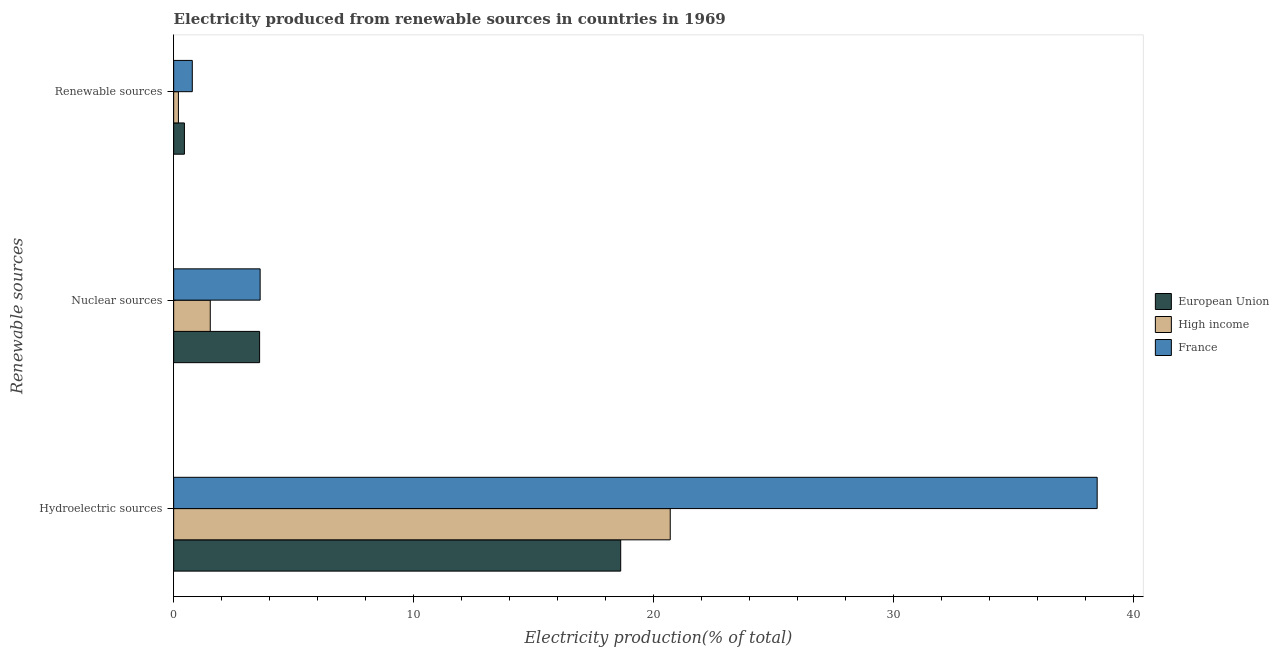How many different coloured bars are there?
Provide a short and direct response. 3. How many groups of bars are there?
Ensure brevity in your answer.  3. Are the number of bars per tick equal to the number of legend labels?
Offer a very short reply. Yes. How many bars are there on the 1st tick from the top?
Offer a very short reply. 3. How many bars are there on the 2nd tick from the bottom?
Offer a very short reply. 3. What is the label of the 1st group of bars from the top?
Provide a short and direct response. Renewable sources. What is the percentage of electricity produced by nuclear sources in France?
Ensure brevity in your answer.  3.6. Across all countries, what is the maximum percentage of electricity produced by nuclear sources?
Ensure brevity in your answer.  3.6. Across all countries, what is the minimum percentage of electricity produced by renewable sources?
Give a very brief answer. 0.2. What is the total percentage of electricity produced by nuclear sources in the graph?
Your answer should be compact. 8.71. What is the difference between the percentage of electricity produced by renewable sources in France and that in High income?
Provide a short and direct response. 0.58. What is the difference between the percentage of electricity produced by renewable sources in High income and the percentage of electricity produced by nuclear sources in European Union?
Your response must be concise. -3.38. What is the average percentage of electricity produced by hydroelectric sources per country?
Make the answer very short. 25.95. What is the difference between the percentage of electricity produced by renewable sources and percentage of electricity produced by hydroelectric sources in European Union?
Provide a short and direct response. -18.19. In how many countries, is the percentage of electricity produced by renewable sources greater than 32 %?
Give a very brief answer. 0. What is the ratio of the percentage of electricity produced by renewable sources in High income to that in European Union?
Your answer should be very brief. 0.44. Is the difference between the percentage of electricity produced by hydroelectric sources in France and High income greater than the difference between the percentage of electricity produced by nuclear sources in France and High income?
Your answer should be very brief. Yes. What is the difference between the highest and the second highest percentage of electricity produced by renewable sources?
Give a very brief answer. 0.33. What is the difference between the highest and the lowest percentage of electricity produced by hydroelectric sources?
Your answer should be compact. 19.87. What does the 2nd bar from the top in Hydroelectric sources represents?
Provide a succinct answer. High income. Is it the case that in every country, the sum of the percentage of electricity produced by hydroelectric sources and percentage of electricity produced by nuclear sources is greater than the percentage of electricity produced by renewable sources?
Make the answer very short. Yes. How many bars are there?
Ensure brevity in your answer.  9. Are all the bars in the graph horizontal?
Keep it short and to the point. Yes. What is the difference between two consecutive major ticks on the X-axis?
Provide a succinct answer. 10. Where does the legend appear in the graph?
Ensure brevity in your answer.  Center right. How many legend labels are there?
Your answer should be compact. 3. How are the legend labels stacked?
Offer a very short reply. Vertical. What is the title of the graph?
Make the answer very short. Electricity produced from renewable sources in countries in 1969. Does "Albania" appear as one of the legend labels in the graph?
Offer a very short reply. No. What is the label or title of the X-axis?
Your response must be concise. Electricity production(% of total). What is the label or title of the Y-axis?
Your response must be concise. Renewable sources. What is the Electricity production(% of total) in European Union in Hydroelectric sources?
Ensure brevity in your answer.  18.64. What is the Electricity production(% of total) in High income in Hydroelectric sources?
Provide a short and direct response. 20.7. What is the Electricity production(% of total) in France in Hydroelectric sources?
Provide a succinct answer. 38.5. What is the Electricity production(% of total) of European Union in Nuclear sources?
Give a very brief answer. 3.58. What is the Electricity production(% of total) of High income in Nuclear sources?
Offer a terse response. 1.53. What is the Electricity production(% of total) in France in Nuclear sources?
Offer a very short reply. 3.6. What is the Electricity production(% of total) in European Union in Renewable sources?
Your answer should be very brief. 0.45. What is the Electricity production(% of total) in High income in Renewable sources?
Provide a short and direct response. 0.2. What is the Electricity production(% of total) in France in Renewable sources?
Provide a succinct answer. 0.78. Across all Renewable sources, what is the maximum Electricity production(% of total) in European Union?
Provide a succinct answer. 18.64. Across all Renewable sources, what is the maximum Electricity production(% of total) of High income?
Offer a very short reply. 20.7. Across all Renewable sources, what is the maximum Electricity production(% of total) of France?
Offer a terse response. 38.5. Across all Renewable sources, what is the minimum Electricity production(% of total) in European Union?
Keep it short and to the point. 0.45. Across all Renewable sources, what is the minimum Electricity production(% of total) in High income?
Your answer should be compact. 0.2. Across all Renewable sources, what is the minimum Electricity production(% of total) in France?
Provide a succinct answer. 0.78. What is the total Electricity production(% of total) in European Union in the graph?
Your answer should be compact. 22.67. What is the total Electricity production(% of total) of High income in the graph?
Provide a succinct answer. 22.43. What is the total Electricity production(% of total) of France in the graph?
Your answer should be very brief. 42.88. What is the difference between the Electricity production(% of total) of European Union in Hydroelectric sources and that in Nuclear sources?
Offer a very short reply. 15.05. What is the difference between the Electricity production(% of total) of High income in Hydroelectric sources and that in Nuclear sources?
Your answer should be very brief. 19.18. What is the difference between the Electricity production(% of total) in France in Hydroelectric sources and that in Nuclear sources?
Offer a very short reply. 34.9. What is the difference between the Electricity production(% of total) of European Union in Hydroelectric sources and that in Renewable sources?
Keep it short and to the point. 18.19. What is the difference between the Electricity production(% of total) in High income in Hydroelectric sources and that in Renewable sources?
Offer a very short reply. 20.5. What is the difference between the Electricity production(% of total) of France in Hydroelectric sources and that in Renewable sources?
Give a very brief answer. 37.73. What is the difference between the Electricity production(% of total) of European Union in Nuclear sources and that in Renewable sources?
Provide a succinct answer. 3.13. What is the difference between the Electricity production(% of total) of High income in Nuclear sources and that in Renewable sources?
Offer a very short reply. 1.33. What is the difference between the Electricity production(% of total) of France in Nuclear sources and that in Renewable sources?
Make the answer very short. 2.83. What is the difference between the Electricity production(% of total) of European Union in Hydroelectric sources and the Electricity production(% of total) of High income in Nuclear sources?
Your answer should be very brief. 17.11. What is the difference between the Electricity production(% of total) in European Union in Hydroelectric sources and the Electricity production(% of total) in France in Nuclear sources?
Make the answer very short. 15.03. What is the difference between the Electricity production(% of total) of High income in Hydroelectric sources and the Electricity production(% of total) of France in Nuclear sources?
Ensure brevity in your answer.  17.1. What is the difference between the Electricity production(% of total) of European Union in Hydroelectric sources and the Electricity production(% of total) of High income in Renewable sources?
Keep it short and to the point. 18.44. What is the difference between the Electricity production(% of total) in European Union in Hydroelectric sources and the Electricity production(% of total) in France in Renewable sources?
Your answer should be compact. 17.86. What is the difference between the Electricity production(% of total) in High income in Hydroelectric sources and the Electricity production(% of total) in France in Renewable sources?
Ensure brevity in your answer.  19.93. What is the difference between the Electricity production(% of total) of European Union in Nuclear sources and the Electricity production(% of total) of High income in Renewable sources?
Provide a short and direct response. 3.38. What is the difference between the Electricity production(% of total) of European Union in Nuclear sources and the Electricity production(% of total) of France in Renewable sources?
Your response must be concise. 2.81. What is the difference between the Electricity production(% of total) in High income in Nuclear sources and the Electricity production(% of total) in France in Renewable sources?
Your answer should be compact. 0.75. What is the average Electricity production(% of total) of European Union per Renewable sources?
Your answer should be compact. 7.56. What is the average Electricity production(% of total) in High income per Renewable sources?
Make the answer very short. 7.48. What is the average Electricity production(% of total) in France per Renewable sources?
Keep it short and to the point. 14.29. What is the difference between the Electricity production(% of total) in European Union and Electricity production(% of total) in High income in Hydroelectric sources?
Offer a very short reply. -2.07. What is the difference between the Electricity production(% of total) in European Union and Electricity production(% of total) in France in Hydroelectric sources?
Provide a short and direct response. -19.87. What is the difference between the Electricity production(% of total) of High income and Electricity production(% of total) of France in Hydroelectric sources?
Provide a succinct answer. -17.8. What is the difference between the Electricity production(% of total) in European Union and Electricity production(% of total) in High income in Nuclear sources?
Make the answer very short. 2.06. What is the difference between the Electricity production(% of total) in European Union and Electricity production(% of total) in France in Nuclear sources?
Ensure brevity in your answer.  -0.02. What is the difference between the Electricity production(% of total) of High income and Electricity production(% of total) of France in Nuclear sources?
Ensure brevity in your answer.  -2.08. What is the difference between the Electricity production(% of total) of European Union and Electricity production(% of total) of High income in Renewable sources?
Keep it short and to the point. 0.25. What is the difference between the Electricity production(% of total) in European Union and Electricity production(% of total) in France in Renewable sources?
Offer a terse response. -0.33. What is the difference between the Electricity production(% of total) in High income and Electricity production(% of total) in France in Renewable sources?
Provide a short and direct response. -0.58. What is the ratio of the Electricity production(% of total) in European Union in Hydroelectric sources to that in Nuclear sources?
Keep it short and to the point. 5.2. What is the ratio of the Electricity production(% of total) of High income in Hydroelectric sources to that in Nuclear sources?
Ensure brevity in your answer.  13.57. What is the ratio of the Electricity production(% of total) in France in Hydroelectric sources to that in Nuclear sources?
Provide a succinct answer. 10.68. What is the ratio of the Electricity production(% of total) in European Union in Hydroelectric sources to that in Renewable sources?
Offer a very short reply. 41.6. What is the ratio of the Electricity production(% of total) in High income in Hydroelectric sources to that in Renewable sources?
Your answer should be very brief. 104.64. What is the ratio of the Electricity production(% of total) in France in Hydroelectric sources to that in Renewable sources?
Offer a terse response. 49.61. What is the ratio of the Electricity production(% of total) of European Union in Nuclear sources to that in Renewable sources?
Offer a terse response. 8. What is the ratio of the Electricity production(% of total) of High income in Nuclear sources to that in Renewable sources?
Make the answer very short. 7.71. What is the ratio of the Electricity production(% of total) in France in Nuclear sources to that in Renewable sources?
Keep it short and to the point. 4.64. What is the difference between the highest and the second highest Electricity production(% of total) in European Union?
Offer a very short reply. 15.05. What is the difference between the highest and the second highest Electricity production(% of total) of High income?
Make the answer very short. 19.18. What is the difference between the highest and the second highest Electricity production(% of total) in France?
Your answer should be very brief. 34.9. What is the difference between the highest and the lowest Electricity production(% of total) in European Union?
Offer a very short reply. 18.19. What is the difference between the highest and the lowest Electricity production(% of total) of High income?
Your answer should be very brief. 20.5. What is the difference between the highest and the lowest Electricity production(% of total) of France?
Provide a short and direct response. 37.73. 